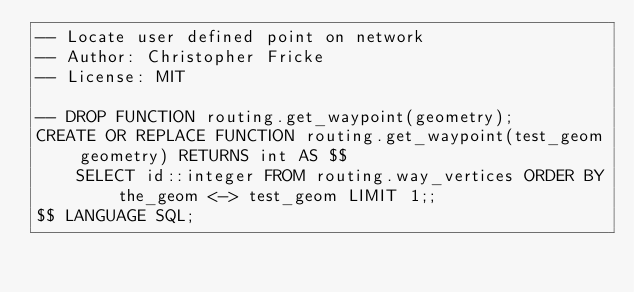Convert code to text. <code><loc_0><loc_0><loc_500><loc_500><_SQL_>-- Locate user defined point on network
-- Author: Christopher Fricke
-- License: MIT

-- DROP FUNCTION routing.get_waypoint(geometry);
CREATE OR REPLACE FUNCTION routing.get_waypoint(test_geom geometry) RETURNS int AS $$
    SELECT id::integer FROM routing.way_vertices ORDER BY the_geom <-> test_geom LIMIT 1;;
$$ LANGUAGE SQL;
</code> 